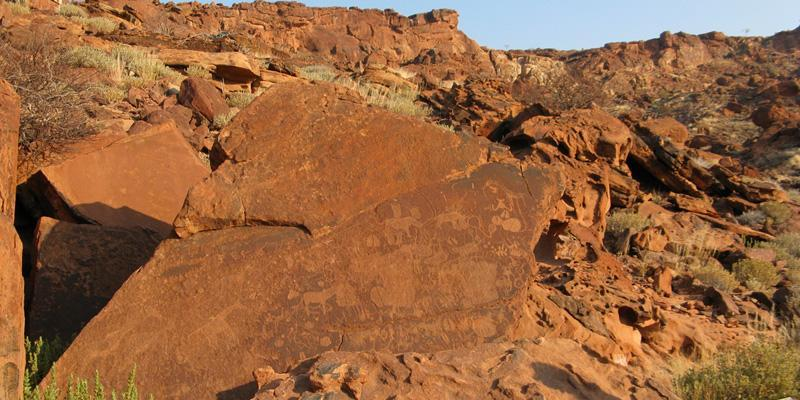Analyze the image in a comprehensive and detailed manner. This photograph presents a remarkable view of the Twyfelfontein rock engravings in Namibia, known for its rich assortment of ancient petroglyphs. In the immediate foreground, a sizable, reddish-brown rock is the focal point, adorned with intricate carvings of animals such as giraffes, lions, and antelopes, along with abstract symbols. These engravings, etched by the early San people, provide a fascinating glimpse into their life and beliefs.

Surrounding the central rock, the landscape is characterized by a rugged, rocky hillside, reinforcing the harsh and arid conditions of the region. Sparse vegetation, consisting mostly of small shrubs and grasses, struggles to thrive amidst the rocky terrain. These natural elements complement the resilience of the ancient engravings that have withstood the test of time and weather.

The image is taken from a low angle perspective, which accentuates the grandeur and historical significance of the rock art, situating it against the backdrop of a vast and bright blue sky. The stark contrast between the sky and the earthy hues of the landscape enhances the depth and visual appeal of the photograph. This snapshot immortalizes Twyfelfontein as a historical and cultural marvel beneath the expansive Namibian sky. 